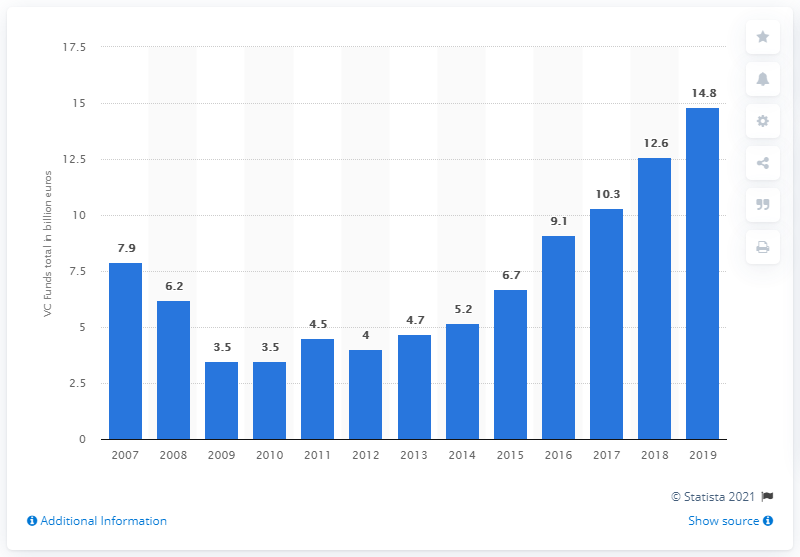Point out several critical features in this image. In 2012, the total value of venture capital investments increased. In 2019, the total value of venture capital funds raised was 14.8 billion dollars. 